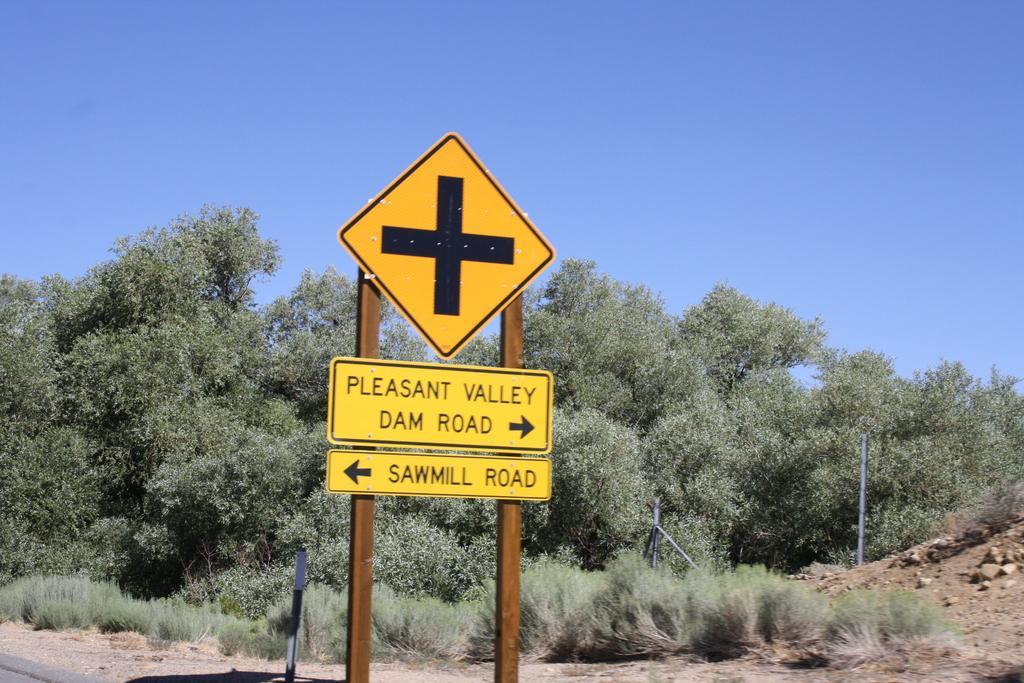Can you describe this image briefly? In the picture we can see a sign board and under it we can see two direction boards to the iron stand and behind it, we can see grass plants, bushes, trees, and besides we can see some stones and in the background we can see a sky. 